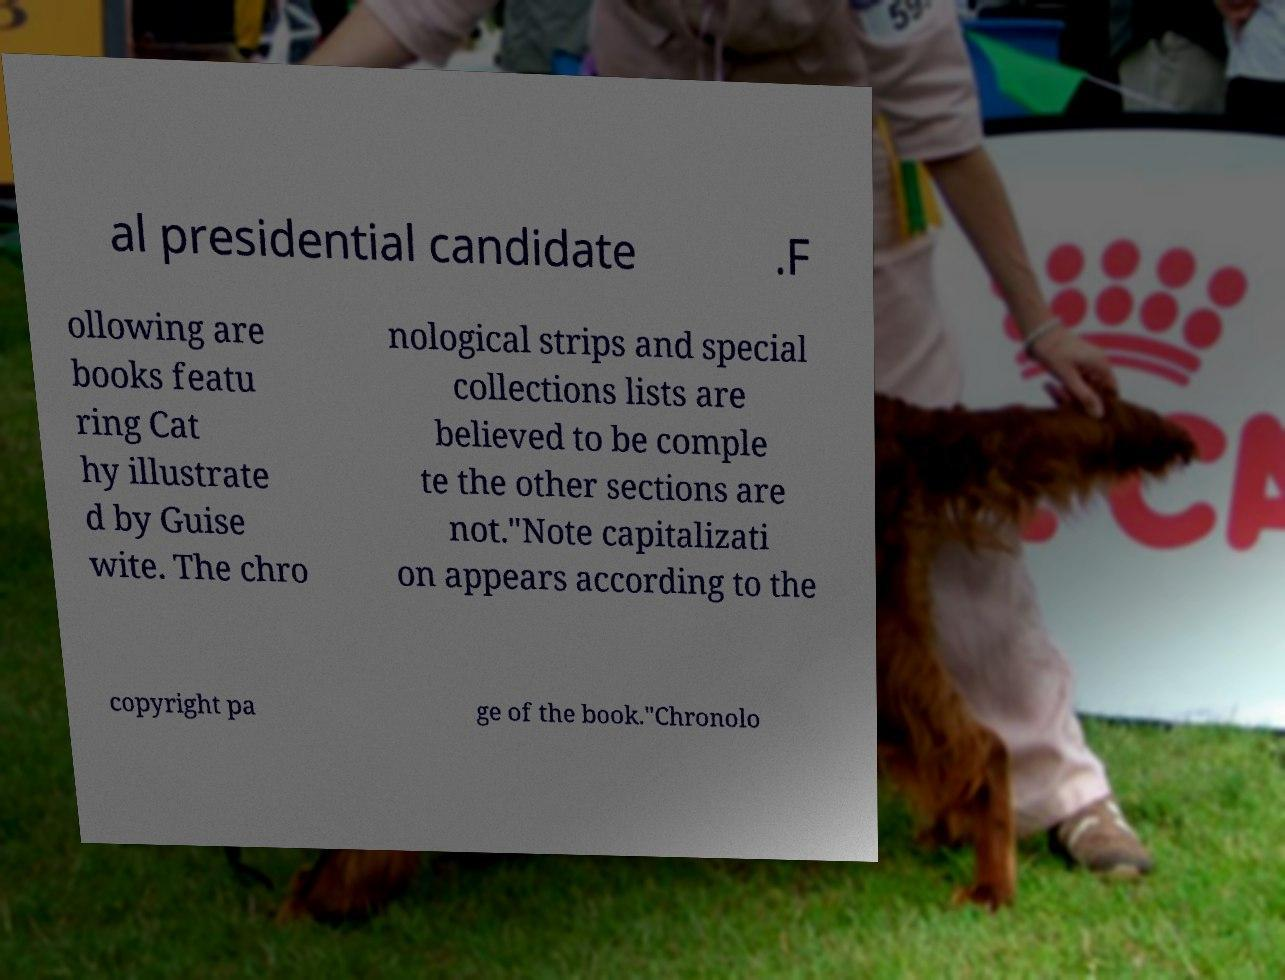What messages or text are displayed in this image? I need them in a readable, typed format. al presidential candidate .F ollowing are books featu ring Cat hy illustrate d by Guise wite. The chro nological strips and special collections lists are believed to be comple te the other sections are not."Note capitalizati on appears according to the copyright pa ge of the book."Chronolo 